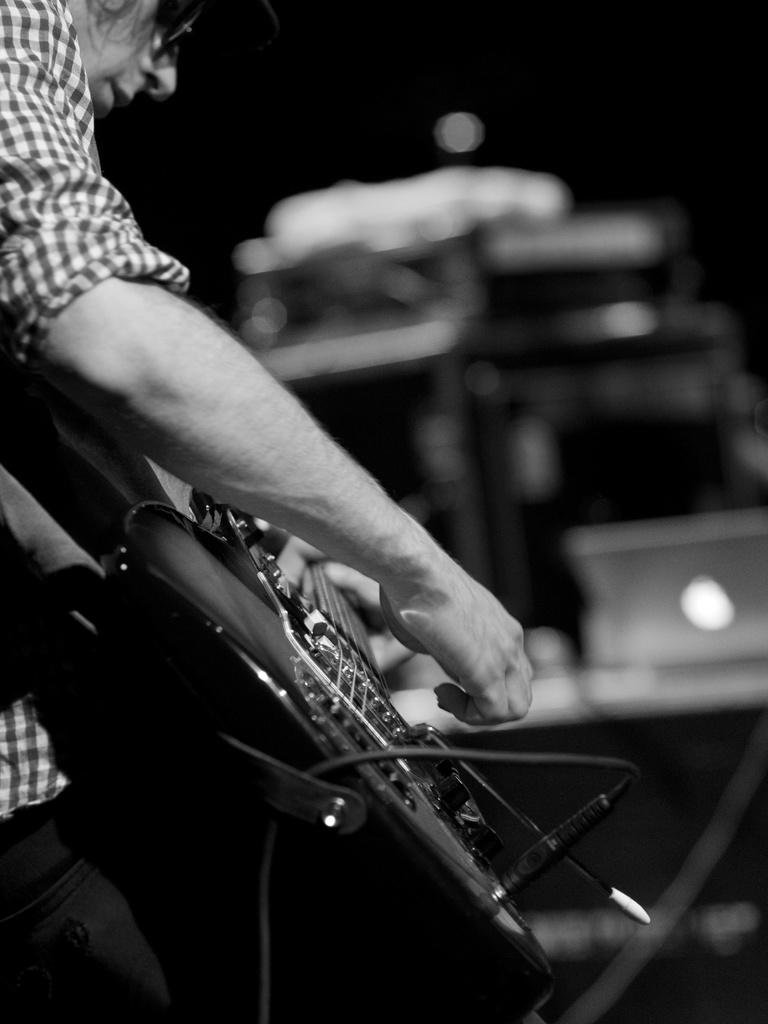What is the main subject of the image? There is a person in the image. What is the person holding in the image? The person is holding a guitar. Can you describe the person's appearance? The person is wearing spectacles. How would you describe the background of the image? The background of the image is blurry. What type of sack can be seen in the image? There is no sack present in the image. How does the person bite the guitar in the image? The person is not biting the guitar in the image; they are holding it. 